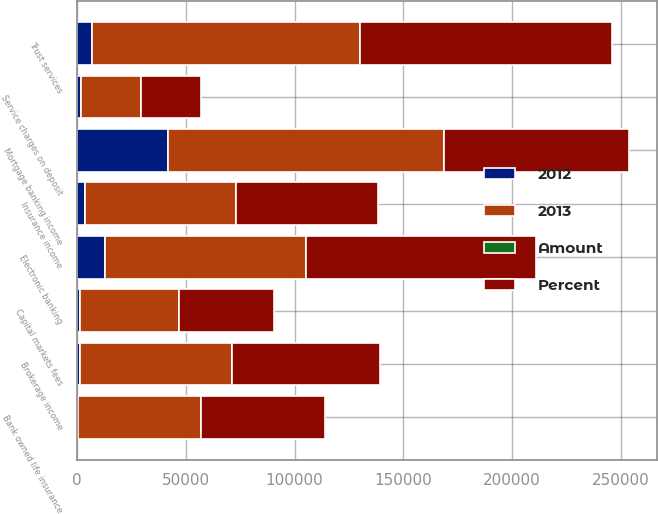Convert chart. <chart><loc_0><loc_0><loc_500><loc_500><stacked_bar_chart><ecel><fcel>Service charges on deposit<fcel>Trust services<fcel>Electronic banking<fcel>Mortgage banking income<fcel>Brokerage income<fcel>Insurance income<fcel>Bank owned life insurance<fcel>Capital markets fees<nl><fcel>Percent<fcel>27389<fcel>115972<fcel>105401<fcel>84887<fcel>68277<fcel>65473<fcel>57048<fcel>43731<nl><fcel>2012<fcel>1939<fcel>7035<fcel>12810<fcel>41968<fcel>1347<fcel>3791<fcel>629<fcel>1489<nl><fcel>Amount<fcel>1<fcel>6<fcel>14<fcel>33<fcel>2<fcel>5<fcel>1<fcel>3<nl><fcel>2013<fcel>27389<fcel>123007<fcel>92591<fcel>126855<fcel>69624<fcel>69264<fcel>56419<fcel>45220<nl></chart> 